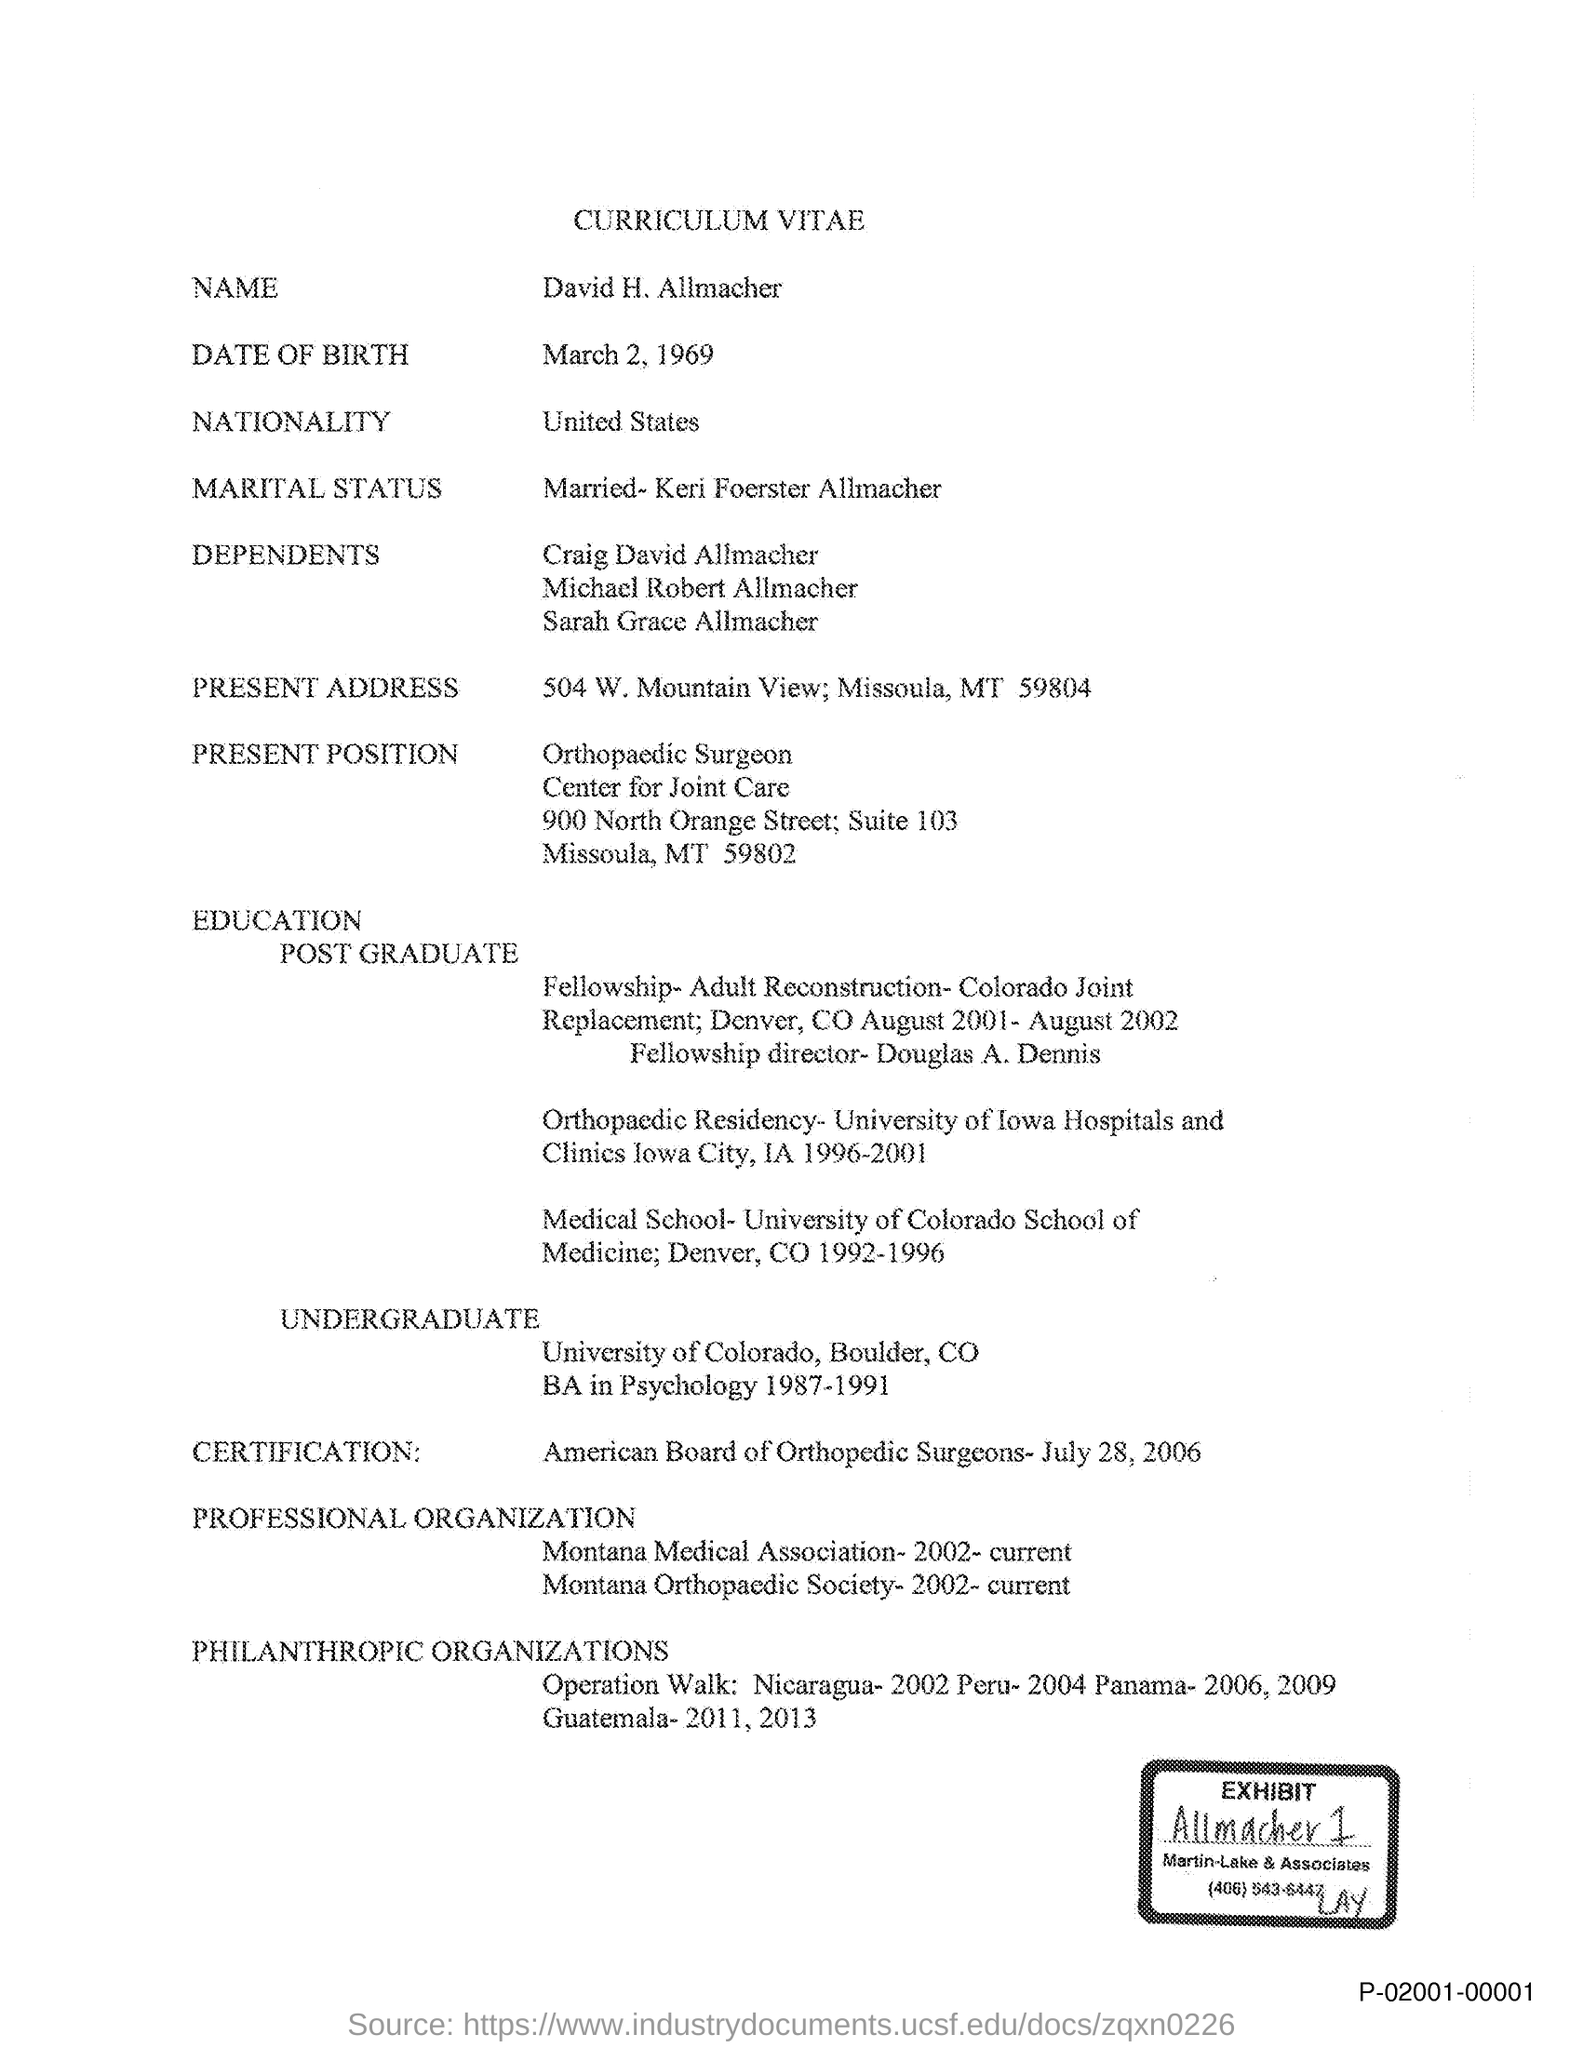Draw attention to some important aspects in this diagram. The vitae of David H. Allmacher is presented in this document. David H. Allmacher is a citizen of the United States. David H. Allmacher completed his Bachelor of Arts degree in Psychology during the years 1987 to 1991. 